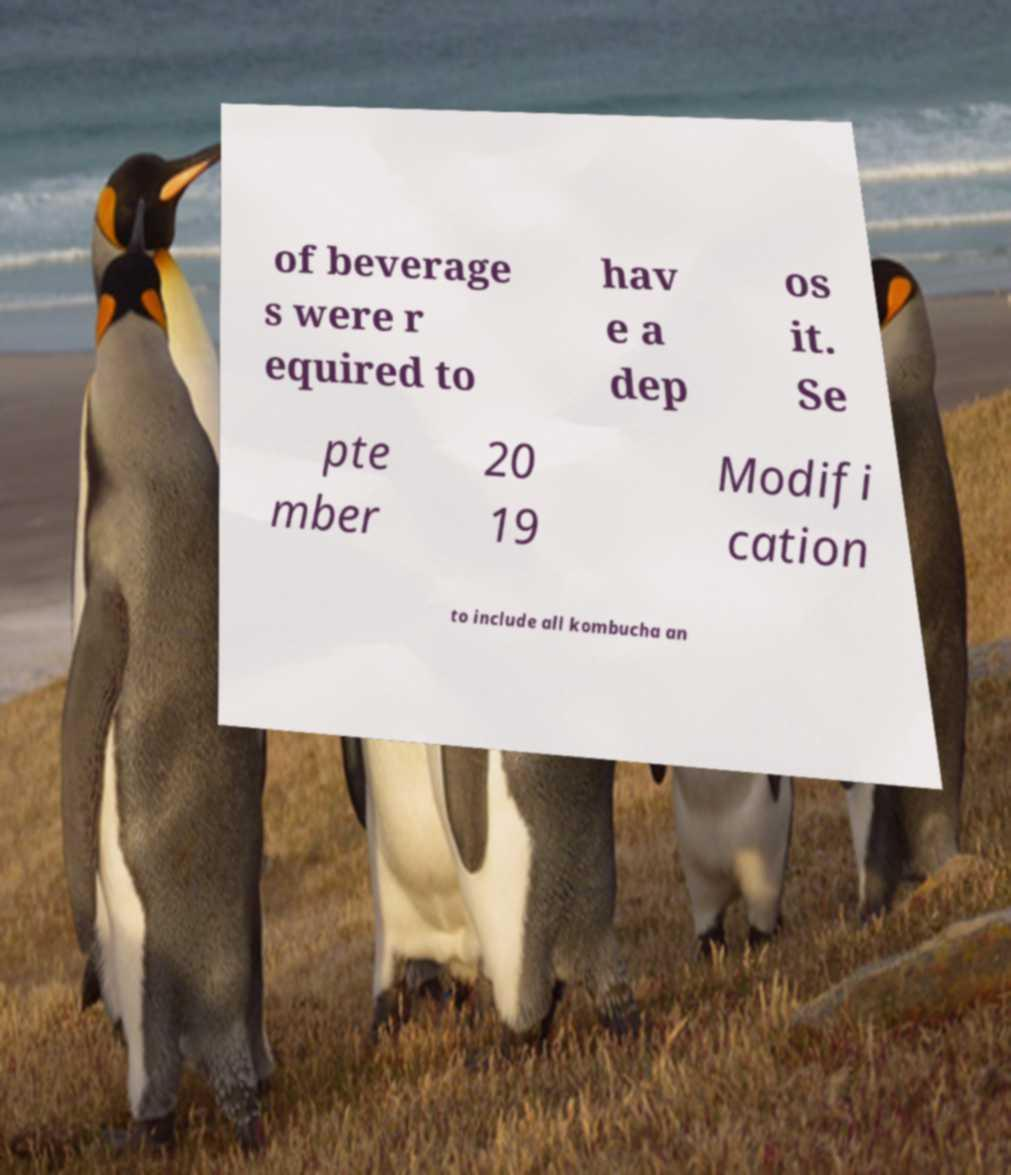Can you accurately transcribe the text from the provided image for me? of beverage s were r equired to hav e a dep os it. Se pte mber 20 19 Modifi cation to include all kombucha an 